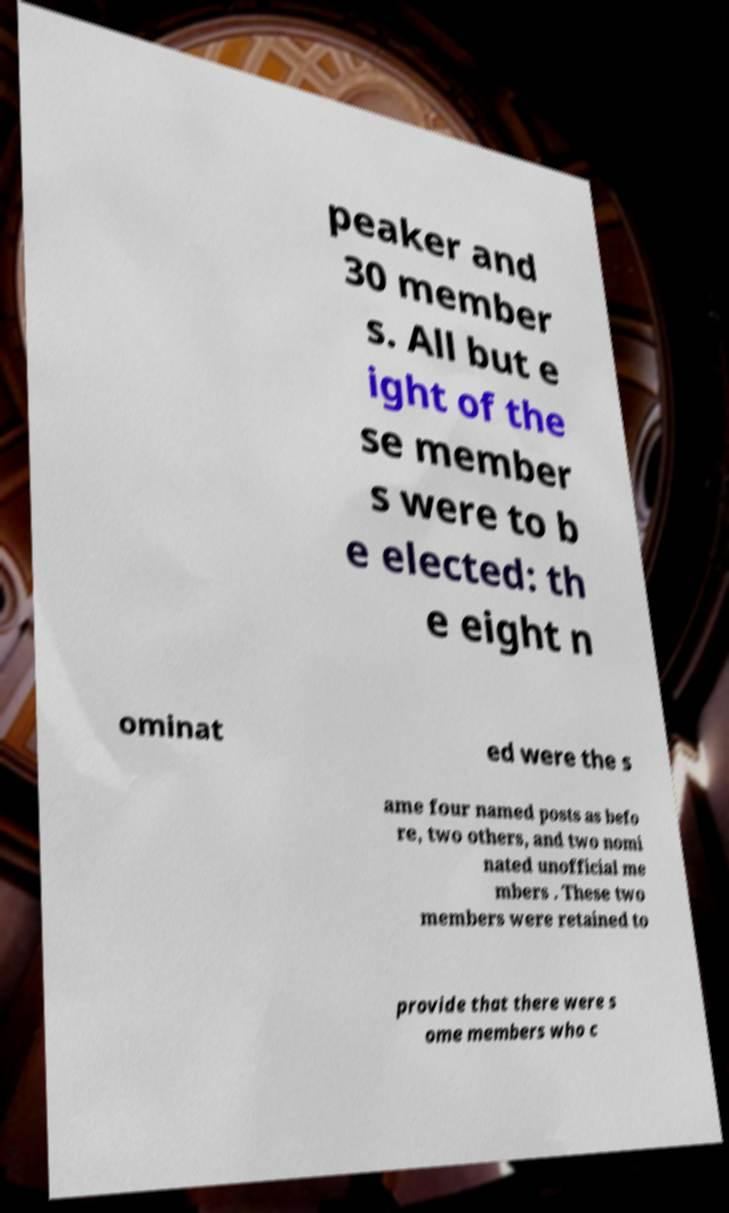What messages or text are displayed in this image? I need them in a readable, typed format. peaker and 30 member s. All but e ight of the se member s were to b e elected: th e eight n ominat ed were the s ame four named posts as befo re, two others, and two nomi nated unofficial me mbers . These two members were retained to provide that there were s ome members who c 